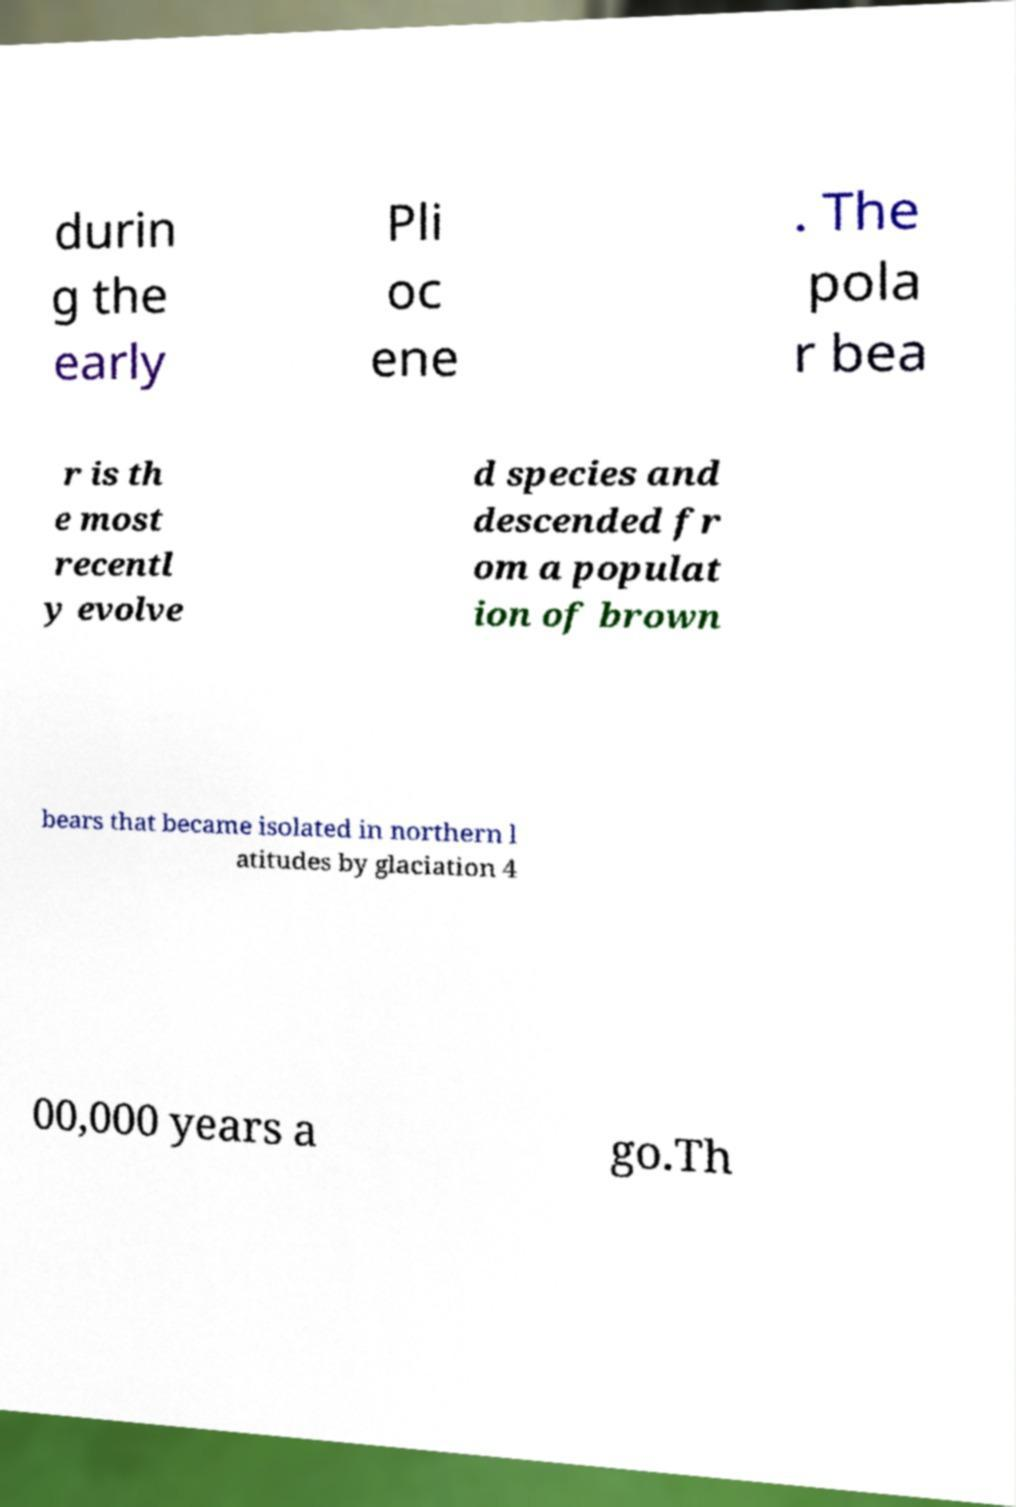I need the written content from this picture converted into text. Can you do that? durin g the early Pli oc ene . The pola r bea r is th e most recentl y evolve d species and descended fr om a populat ion of brown bears that became isolated in northern l atitudes by glaciation 4 00,000 years a go.Th 